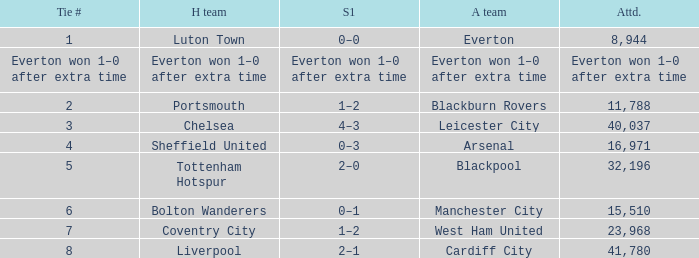What home team had an attendance record of 16,971? Sheffield United. 